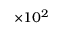<formula> <loc_0><loc_0><loc_500><loc_500>\times 1 0 ^ { 2 }</formula> 